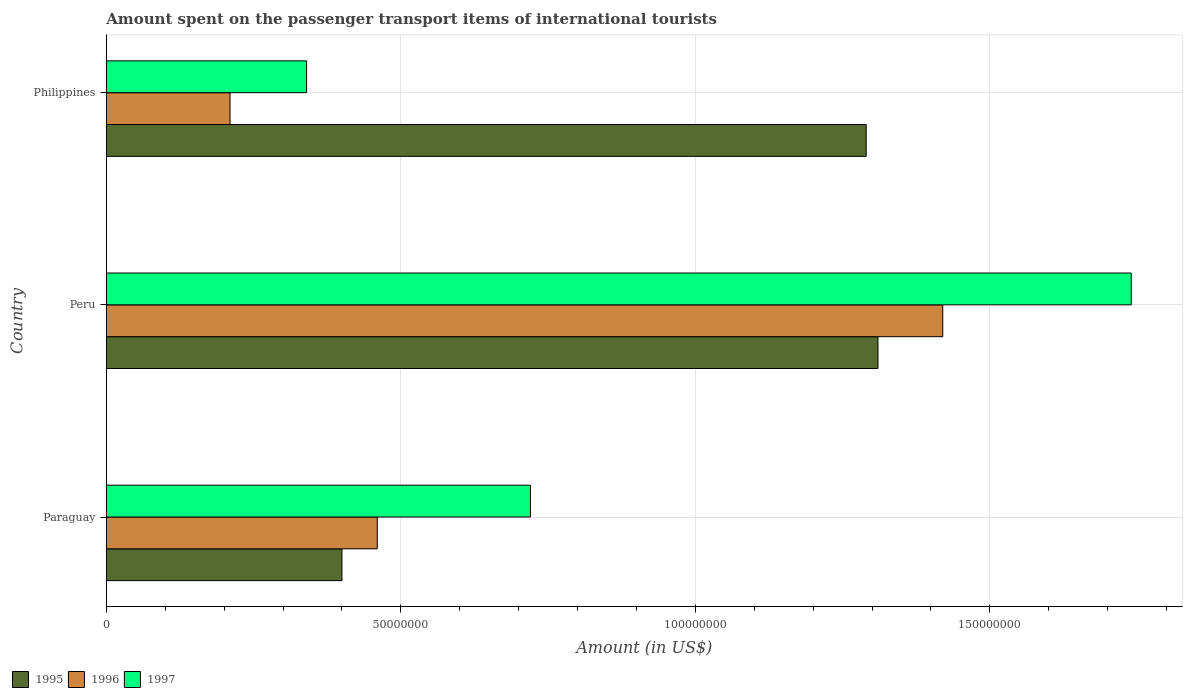How many different coloured bars are there?
Offer a very short reply. 3. How many groups of bars are there?
Make the answer very short. 3. Are the number of bars per tick equal to the number of legend labels?
Offer a terse response. Yes. Are the number of bars on each tick of the Y-axis equal?
Provide a succinct answer. Yes. How many bars are there on the 2nd tick from the bottom?
Your answer should be very brief. 3. What is the label of the 2nd group of bars from the top?
Give a very brief answer. Peru. What is the amount spent on the passenger transport items of international tourists in 1997 in Peru?
Offer a very short reply. 1.74e+08. Across all countries, what is the maximum amount spent on the passenger transport items of international tourists in 1996?
Offer a terse response. 1.42e+08. Across all countries, what is the minimum amount spent on the passenger transport items of international tourists in 1996?
Offer a terse response. 2.10e+07. In which country was the amount spent on the passenger transport items of international tourists in 1996 maximum?
Offer a very short reply. Peru. In which country was the amount spent on the passenger transport items of international tourists in 1995 minimum?
Provide a short and direct response. Paraguay. What is the total amount spent on the passenger transport items of international tourists in 1996 in the graph?
Your answer should be very brief. 2.09e+08. What is the difference between the amount spent on the passenger transport items of international tourists in 1996 in Paraguay and that in Peru?
Offer a very short reply. -9.60e+07. What is the difference between the amount spent on the passenger transport items of international tourists in 1997 in Philippines and the amount spent on the passenger transport items of international tourists in 1995 in Paraguay?
Provide a succinct answer. -6.00e+06. What is the average amount spent on the passenger transport items of international tourists in 1996 per country?
Keep it short and to the point. 6.97e+07. What is the difference between the amount spent on the passenger transport items of international tourists in 1995 and amount spent on the passenger transport items of international tourists in 1996 in Philippines?
Offer a terse response. 1.08e+08. In how many countries, is the amount spent on the passenger transport items of international tourists in 1997 greater than 150000000 US$?
Provide a succinct answer. 1. What is the ratio of the amount spent on the passenger transport items of international tourists in 1997 in Peru to that in Philippines?
Ensure brevity in your answer.  5.12. What is the difference between the highest and the second highest amount spent on the passenger transport items of international tourists in 1997?
Provide a succinct answer. 1.02e+08. What is the difference between the highest and the lowest amount spent on the passenger transport items of international tourists in 1995?
Offer a very short reply. 9.10e+07. In how many countries, is the amount spent on the passenger transport items of international tourists in 1997 greater than the average amount spent on the passenger transport items of international tourists in 1997 taken over all countries?
Provide a succinct answer. 1. Is the sum of the amount spent on the passenger transport items of international tourists in 1997 in Paraguay and Peru greater than the maximum amount spent on the passenger transport items of international tourists in 1996 across all countries?
Your response must be concise. Yes. What does the 1st bar from the bottom in Paraguay represents?
Give a very brief answer. 1995. Are all the bars in the graph horizontal?
Make the answer very short. Yes. How many countries are there in the graph?
Make the answer very short. 3. Are the values on the major ticks of X-axis written in scientific E-notation?
Keep it short and to the point. No. Does the graph contain grids?
Your answer should be compact. Yes. Where does the legend appear in the graph?
Ensure brevity in your answer.  Bottom left. How are the legend labels stacked?
Your answer should be very brief. Horizontal. What is the title of the graph?
Your answer should be compact. Amount spent on the passenger transport items of international tourists. What is the Amount (in US$) of 1995 in Paraguay?
Provide a short and direct response. 4.00e+07. What is the Amount (in US$) of 1996 in Paraguay?
Offer a very short reply. 4.60e+07. What is the Amount (in US$) in 1997 in Paraguay?
Your response must be concise. 7.20e+07. What is the Amount (in US$) in 1995 in Peru?
Ensure brevity in your answer.  1.31e+08. What is the Amount (in US$) of 1996 in Peru?
Offer a terse response. 1.42e+08. What is the Amount (in US$) of 1997 in Peru?
Your response must be concise. 1.74e+08. What is the Amount (in US$) of 1995 in Philippines?
Ensure brevity in your answer.  1.29e+08. What is the Amount (in US$) of 1996 in Philippines?
Give a very brief answer. 2.10e+07. What is the Amount (in US$) of 1997 in Philippines?
Your answer should be compact. 3.40e+07. Across all countries, what is the maximum Amount (in US$) of 1995?
Your answer should be very brief. 1.31e+08. Across all countries, what is the maximum Amount (in US$) in 1996?
Your response must be concise. 1.42e+08. Across all countries, what is the maximum Amount (in US$) in 1997?
Your response must be concise. 1.74e+08. Across all countries, what is the minimum Amount (in US$) of 1995?
Provide a succinct answer. 4.00e+07. Across all countries, what is the minimum Amount (in US$) of 1996?
Offer a very short reply. 2.10e+07. Across all countries, what is the minimum Amount (in US$) in 1997?
Offer a very short reply. 3.40e+07. What is the total Amount (in US$) in 1995 in the graph?
Keep it short and to the point. 3.00e+08. What is the total Amount (in US$) of 1996 in the graph?
Your response must be concise. 2.09e+08. What is the total Amount (in US$) of 1997 in the graph?
Offer a very short reply. 2.80e+08. What is the difference between the Amount (in US$) of 1995 in Paraguay and that in Peru?
Give a very brief answer. -9.10e+07. What is the difference between the Amount (in US$) of 1996 in Paraguay and that in Peru?
Make the answer very short. -9.60e+07. What is the difference between the Amount (in US$) of 1997 in Paraguay and that in Peru?
Offer a terse response. -1.02e+08. What is the difference between the Amount (in US$) in 1995 in Paraguay and that in Philippines?
Keep it short and to the point. -8.90e+07. What is the difference between the Amount (in US$) of 1996 in Paraguay and that in Philippines?
Your response must be concise. 2.50e+07. What is the difference between the Amount (in US$) in 1997 in Paraguay and that in Philippines?
Provide a succinct answer. 3.80e+07. What is the difference between the Amount (in US$) of 1996 in Peru and that in Philippines?
Offer a very short reply. 1.21e+08. What is the difference between the Amount (in US$) in 1997 in Peru and that in Philippines?
Your answer should be compact. 1.40e+08. What is the difference between the Amount (in US$) of 1995 in Paraguay and the Amount (in US$) of 1996 in Peru?
Offer a very short reply. -1.02e+08. What is the difference between the Amount (in US$) in 1995 in Paraguay and the Amount (in US$) in 1997 in Peru?
Your response must be concise. -1.34e+08. What is the difference between the Amount (in US$) in 1996 in Paraguay and the Amount (in US$) in 1997 in Peru?
Give a very brief answer. -1.28e+08. What is the difference between the Amount (in US$) in 1995 in Paraguay and the Amount (in US$) in 1996 in Philippines?
Offer a very short reply. 1.90e+07. What is the difference between the Amount (in US$) in 1995 in Paraguay and the Amount (in US$) in 1997 in Philippines?
Provide a short and direct response. 6.00e+06. What is the difference between the Amount (in US$) in 1996 in Paraguay and the Amount (in US$) in 1997 in Philippines?
Keep it short and to the point. 1.20e+07. What is the difference between the Amount (in US$) of 1995 in Peru and the Amount (in US$) of 1996 in Philippines?
Ensure brevity in your answer.  1.10e+08. What is the difference between the Amount (in US$) in 1995 in Peru and the Amount (in US$) in 1997 in Philippines?
Give a very brief answer. 9.70e+07. What is the difference between the Amount (in US$) of 1996 in Peru and the Amount (in US$) of 1997 in Philippines?
Your answer should be compact. 1.08e+08. What is the average Amount (in US$) of 1995 per country?
Offer a terse response. 1.00e+08. What is the average Amount (in US$) of 1996 per country?
Make the answer very short. 6.97e+07. What is the average Amount (in US$) in 1997 per country?
Your answer should be very brief. 9.33e+07. What is the difference between the Amount (in US$) in 1995 and Amount (in US$) in 1996 in Paraguay?
Your answer should be very brief. -6.00e+06. What is the difference between the Amount (in US$) in 1995 and Amount (in US$) in 1997 in Paraguay?
Give a very brief answer. -3.20e+07. What is the difference between the Amount (in US$) in 1996 and Amount (in US$) in 1997 in Paraguay?
Offer a very short reply. -2.60e+07. What is the difference between the Amount (in US$) in 1995 and Amount (in US$) in 1996 in Peru?
Give a very brief answer. -1.10e+07. What is the difference between the Amount (in US$) of 1995 and Amount (in US$) of 1997 in Peru?
Your answer should be compact. -4.30e+07. What is the difference between the Amount (in US$) of 1996 and Amount (in US$) of 1997 in Peru?
Make the answer very short. -3.20e+07. What is the difference between the Amount (in US$) of 1995 and Amount (in US$) of 1996 in Philippines?
Your response must be concise. 1.08e+08. What is the difference between the Amount (in US$) of 1995 and Amount (in US$) of 1997 in Philippines?
Offer a very short reply. 9.50e+07. What is the difference between the Amount (in US$) in 1996 and Amount (in US$) in 1997 in Philippines?
Ensure brevity in your answer.  -1.30e+07. What is the ratio of the Amount (in US$) in 1995 in Paraguay to that in Peru?
Ensure brevity in your answer.  0.31. What is the ratio of the Amount (in US$) of 1996 in Paraguay to that in Peru?
Give a very brief answer. 0.32. What is the ratio of the Amount (in US$) of 1997 in Paraguay to that in Peru?
Keep it short and to the point. 0.41. What is the ratio of the Amount (in US$) of 1995 in Paraguay to that in Philippines?
Make the answer very short. 0.31. What is the ratio of the Amount (in US$) of 1996 in Paraguay to that in Philippines?
Ensure brevity in your answer.  2.19. What is the ratio of the Amount (in US$) of 1997 in Paraguay to that in Philippines?
Your response must be concise. 2.12. What is the ratio of the Amount (in US$) in 1995 in Peru to that in Philippines?
Ensure brevity in your answer.  1.02. What is the ratio of the Amount (in US$) in 1996 in Peru to that in Philippines?
Your answer should be compact. 6.76. What is the ratio of the Amount (in US$) of 1997 in Peru to that in Philippines?
Ensure brevity in your answer.  5.12. What is the difference between the highest and the second highest Amount (in US$) in 1995?
Your response must be concise. 2.00e+06. What is the difference between the highest and the second highest Amount (in US$) in 1996?
Ensure brevity in your answer.  9.60e+07. What is the difference between the highest and the second highest Amount (in US$) of 1997?
Ensure brevity in your answer.  1.02e+08. What is the difference between the highest and the lowest Amount (in US$) of 1995?
Provide a short and direct response. 9.10e+07. What is the difference between the highest and the lowest Amount (in US$) of 1996?
Your answer should be compact. 1.21e+08. What is the difference between the highest and the lowest Amount (in US$) in 1997?
Ensure brevity in your answer.  1.40e+08. 